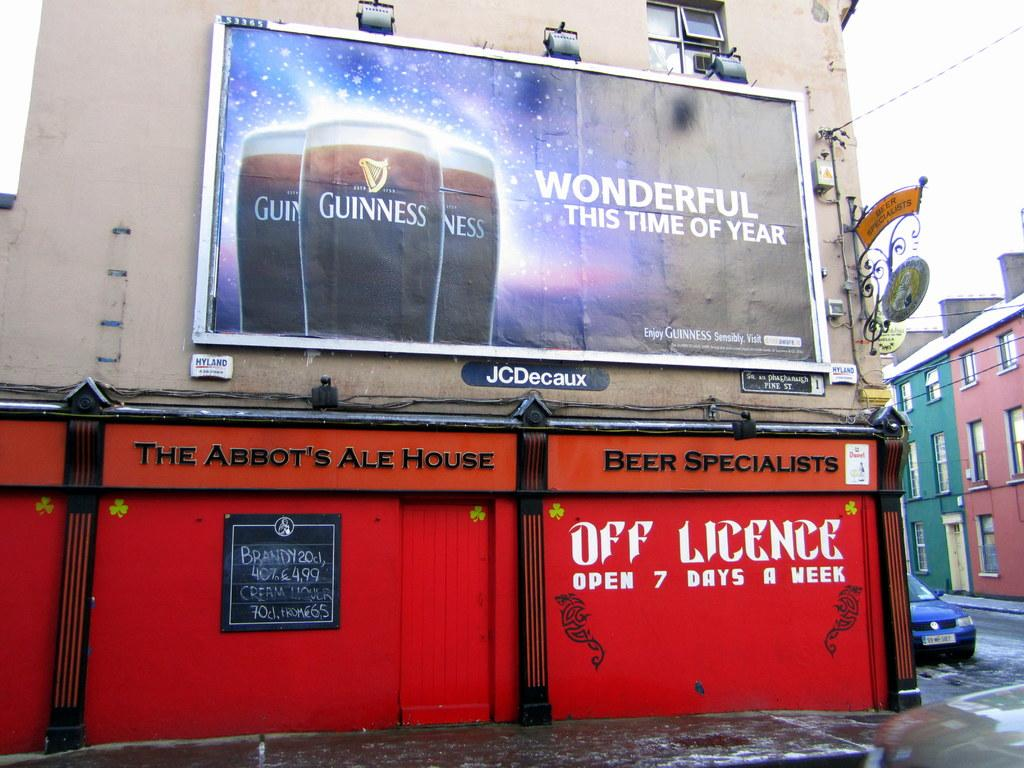<image>
Share a concise interpretation of the image provided. A Guinness billboard above The Abbot's Ale House. 